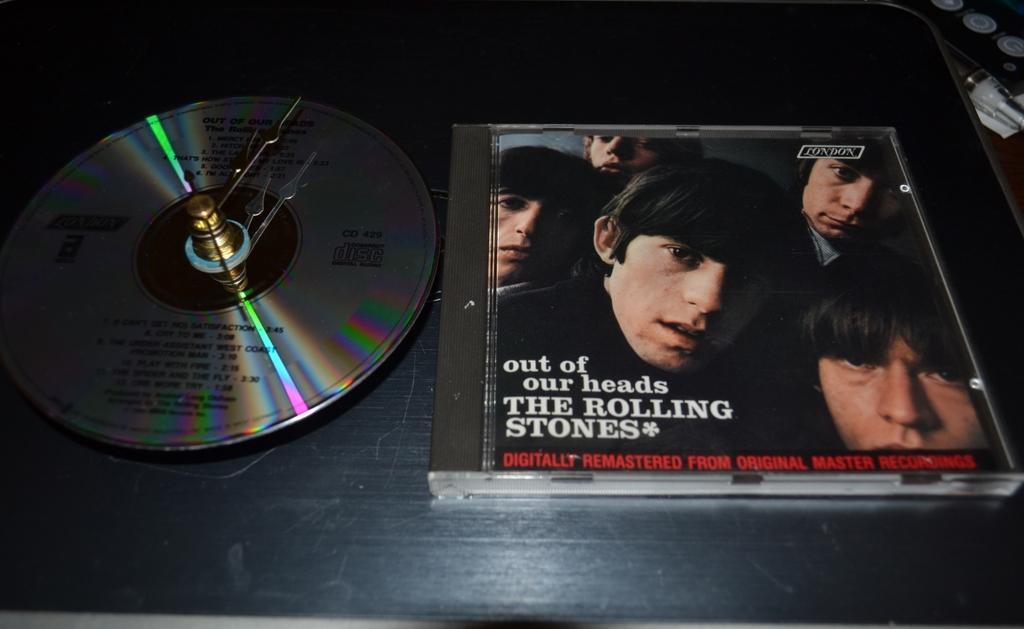Please provide a concise description of this image. In this picture I can observe a DVD placed on the black color surface. On the right side I can observe a DVD box. 